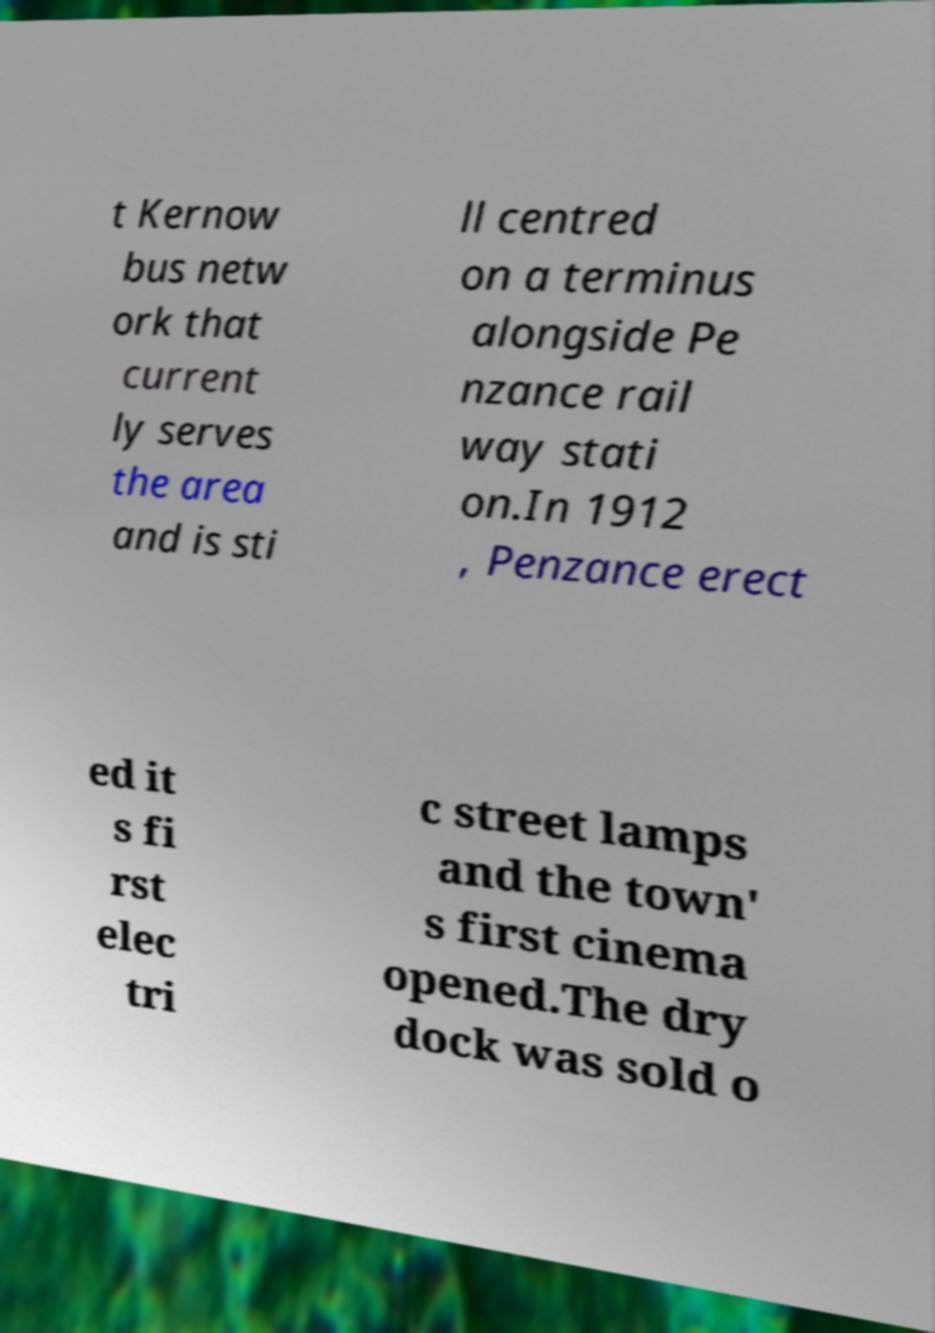There's text embedded in this image that I need extracted. Can you transcribe it verbatim? t Kernow bus netw ork that current ly serves the area and is sti ll centred on a terminus alongside Pe nzance rail way stati on.In 1912 , Penzance erect ed it s fi rst elec tri c street lamps and the town' s first cinema opened.The dry dock was sold o 